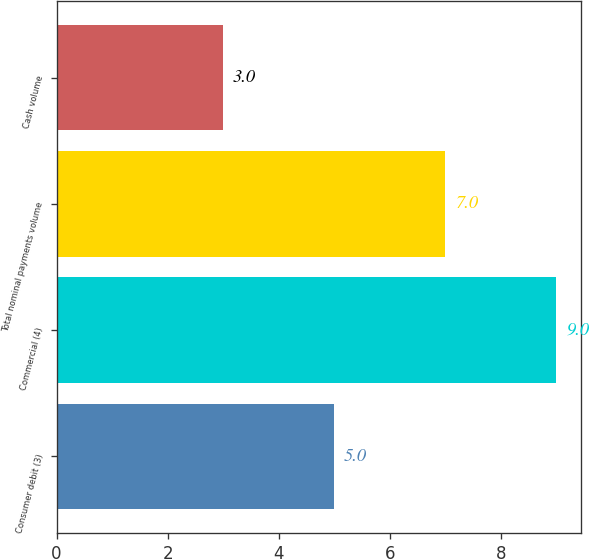Convert chart. <chart><loc_0><loc_0><loc_500><loc_500><bar_chart><fcel>Consumer debit (3)<fcel>Commercial (4)<fcel>Total nominal payments volume<fcel>Cash volume<nl><fcel>5<fcel>9<fcel>7<fcel>3<nl></chart> 